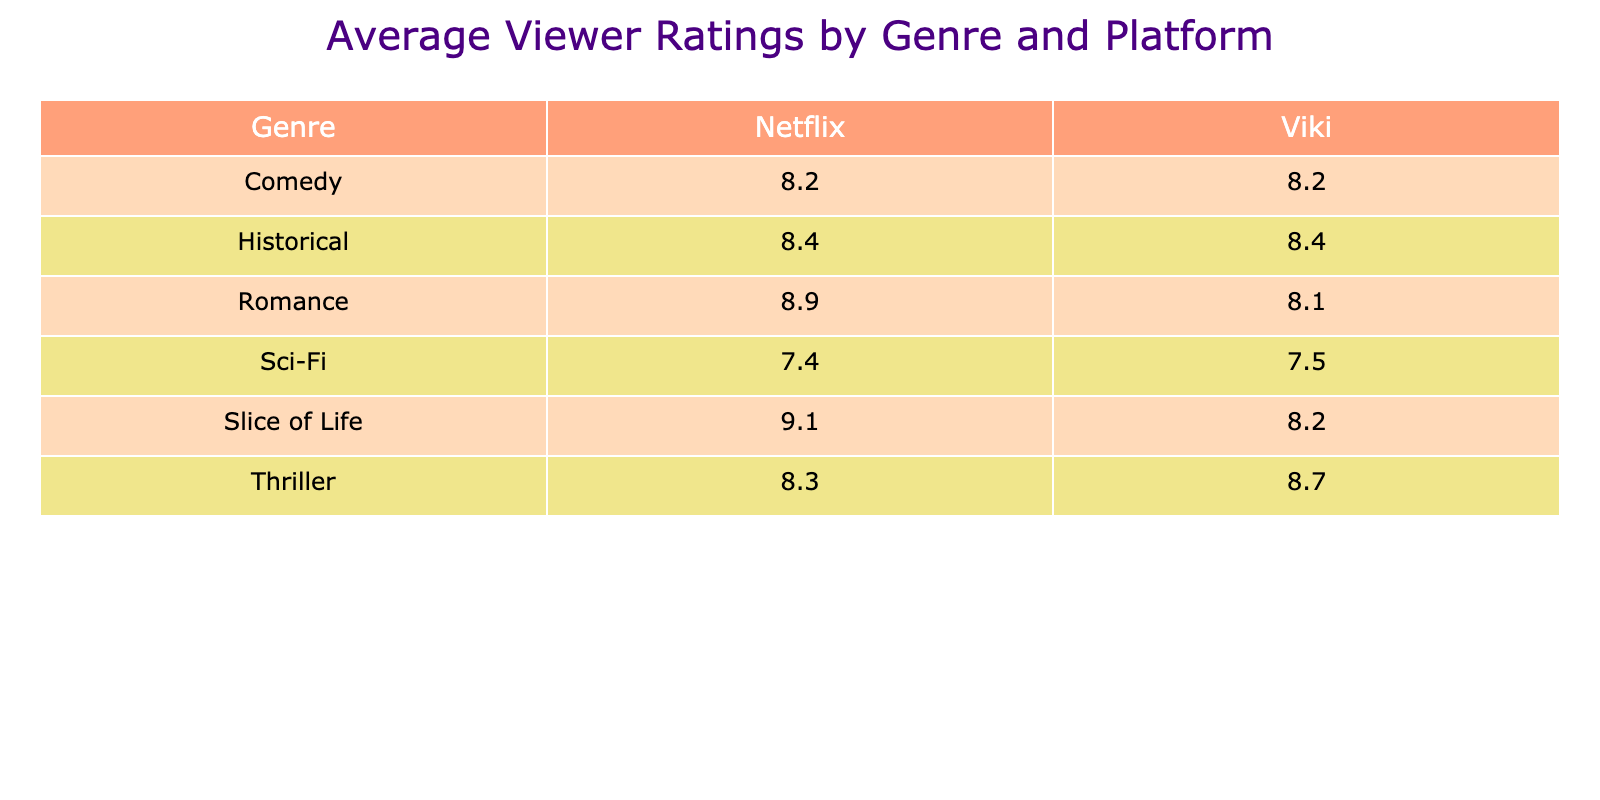What's the average viewer rating for Romance genre on Netflix? The table shows the viewer ratings for the Romance genre on Netflix are 9.2, 8.7, and 8.7. To find the average, add these ratings: 9.2 + 8.7 + 8.7 = 26.6. Then divide by the number of entries, which is 3: 26.6 / 3 = 8.87.
Answer: 8.9 Which platform has the highest average viewer rating for Thrillers? The table lists viewer ratings for Thrillers as follows: Viki has ratings of 8.9, 8.6, and 8.7, which average to (8.9 + 8.7 + 8.6) / 3 = 8.73. Netflix’s ratings are 8.3, giving an average of 8.3. Since 8.73 (Viki) is greater than 8.3 (Netflix), Viki has the highest average rating for Thrillers.
Answer: Viki Is the average viewer rating for Historical dramas on Viki greater than 8.0? The Historical dramas on Viki have ratings of 8.8 and 7.9. To find the average, add these ratings: 8.8 + 7.9 = 16.7, then divide by the number of entries (2): 16.7 / 2 = 8.35. Since 8.35 is greater than 8.0, the answer is yes.
Answer: Yes What is the difference in average viewer rating between Comedy on Netflix and Viki? On Netflix, the Comedy ratings are 8.3 and 8.1, giving an average of (8.3 + 8.1) / 2 = 8.2. On Viki, the rating is 8.2 from "Strong Woman Do Bong Soon." The difference between Netflix's average (8.2) and Viki's average (8.2) is 0. Hence, the difference is 0.
Answer: 0 Which genre has the highest viewer rating and on which platform? By reviewing the table, the highest viewer rating is 9.2 from "Crash Landing on You" in the Romance genre on Netflix. This is the maximum value present in the ratings. Therefore, the answer is Romance on Netflix.
Answer: Romance on Netflix 